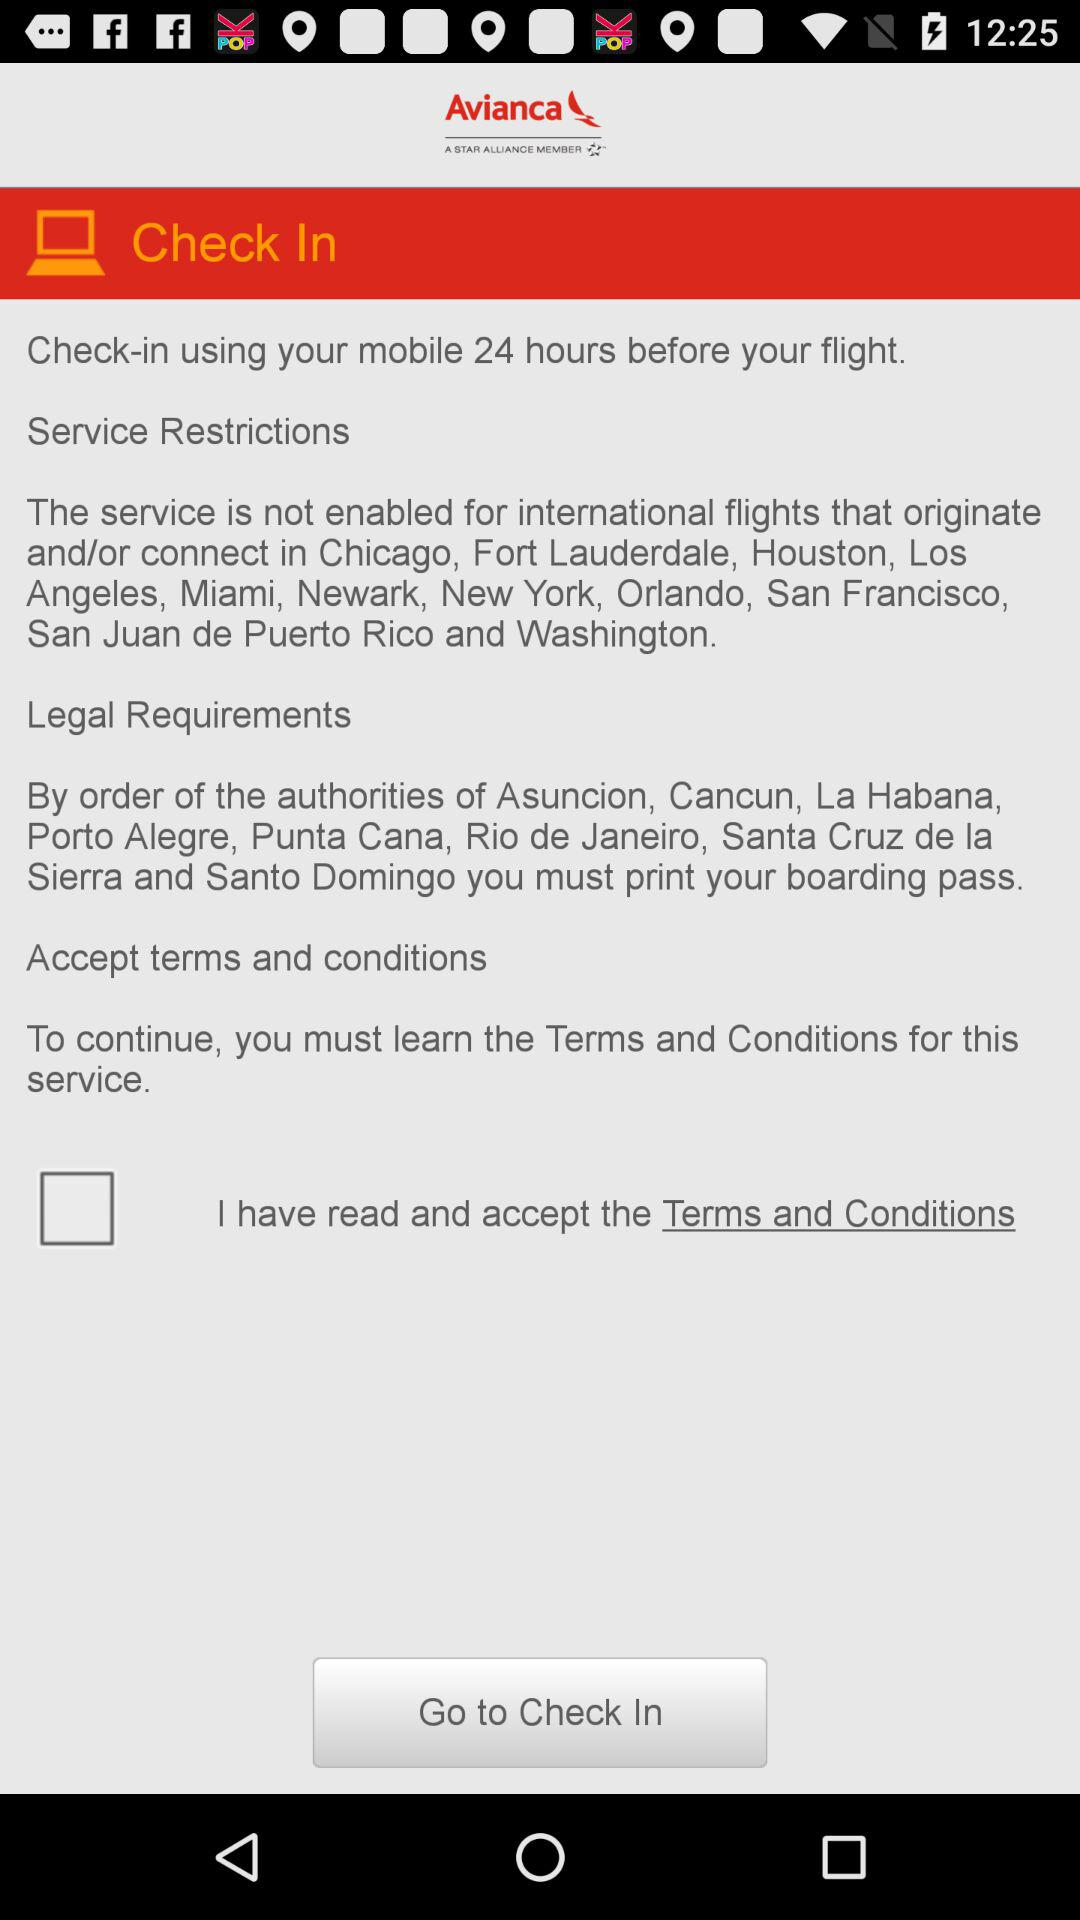What is the status of "I have read and accept the Terms and Conditions"? The status of "I have read and accept the Terms and Conditions" is "off". 